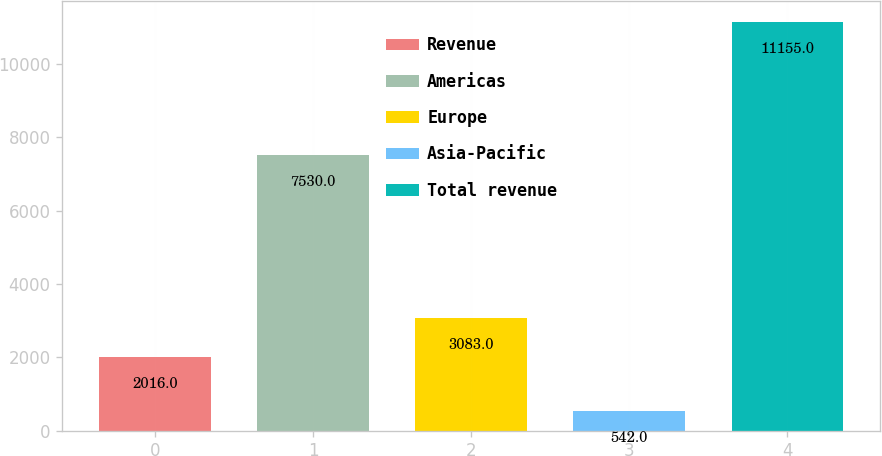Convert chart. <chart><loc_0><loc_0><loc_500><loc_500><bar_chart><fcel>Revenue<fcel>Americas<fcel>Europe<fcel>Asia-Pacific<fcel>Total revenue<nl><fcel>2016<fcel>7530<fcel>3083<fcel>542<fcel>11155<nl></chart> 